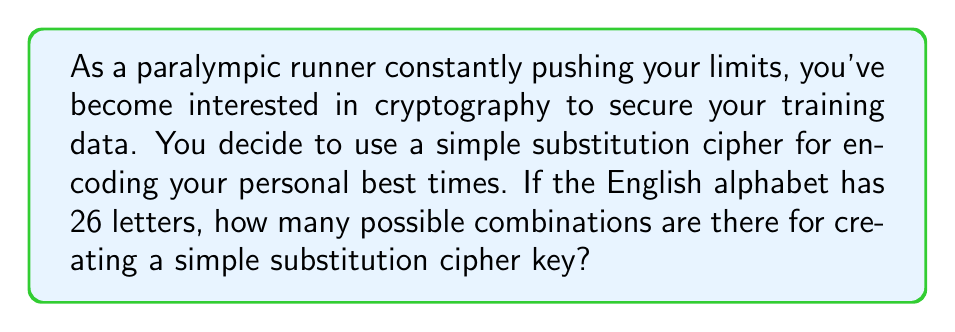Provide a solution to this math problem. Let's approach this step-by-step:

1) In a simple substitution cipher, each letter of the alphabet is replaced by another letter, and no two letters can be replaced by the same letter.

2) This is equivalent to finding the number of ways to arrange 26 distinct letters, which is a permutation problem.

3) We can use the factorial function to calculate this:

   $$26! = 26 \times 25 \times 24 \times ... \times 3 \times 2 \times 1$$

4) This can be written as:

   $$26! = 403291461126605635584000000$$

5) To understand the magnitude, we can express this in scientific notation:

   $$26! \approx 4.03 \times 10^{26}$$

This enormous number of possibilities is what makes simple substitution ciphers difficult to break by brute force, despite their simplicity.
Answer: $26!$ or approximately $4.03 \times 10^{26}$ 